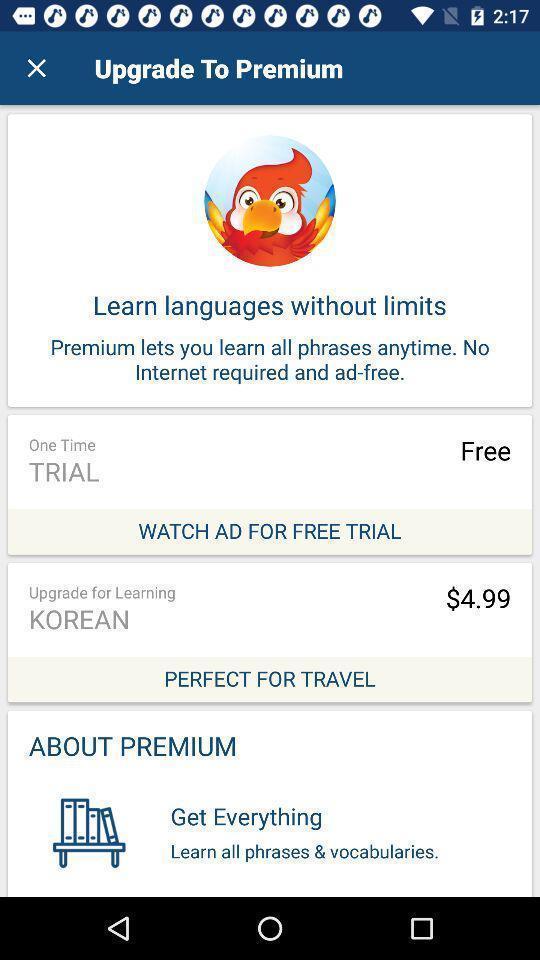Provide a textual representation of this image. Page for upgrading to premium of a language learning app. 